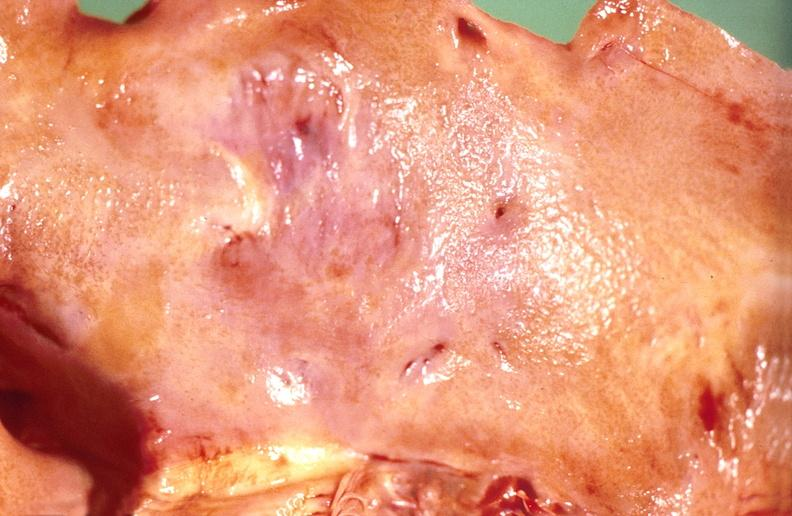s carcinomatosis present?
Answer the question using a single word or phrase. No 